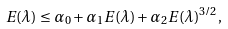<formula> <loc_0><loc_0><loc_500><loc_500>E ( \lambda ) \leq \alpha _ { 0 } + \alpha _ { 1 } E ( \lambda ) + \alpha _ { 2 } E ( \lambda ) ^ { 3 / 2 } ,</formula> 